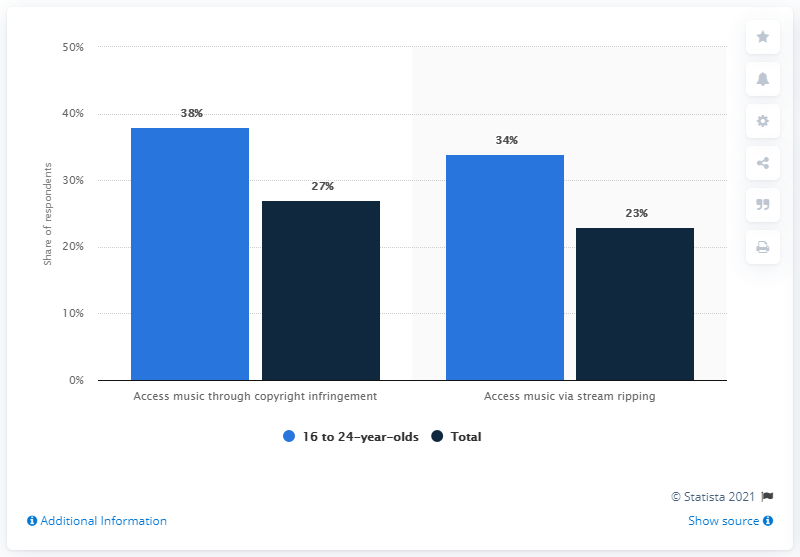Point out several critical features in this image. For those between the ages of 16 and 24, the difference in their use of music through copyright infringement is the highest. Copyright infringement provides the highest access to music. 